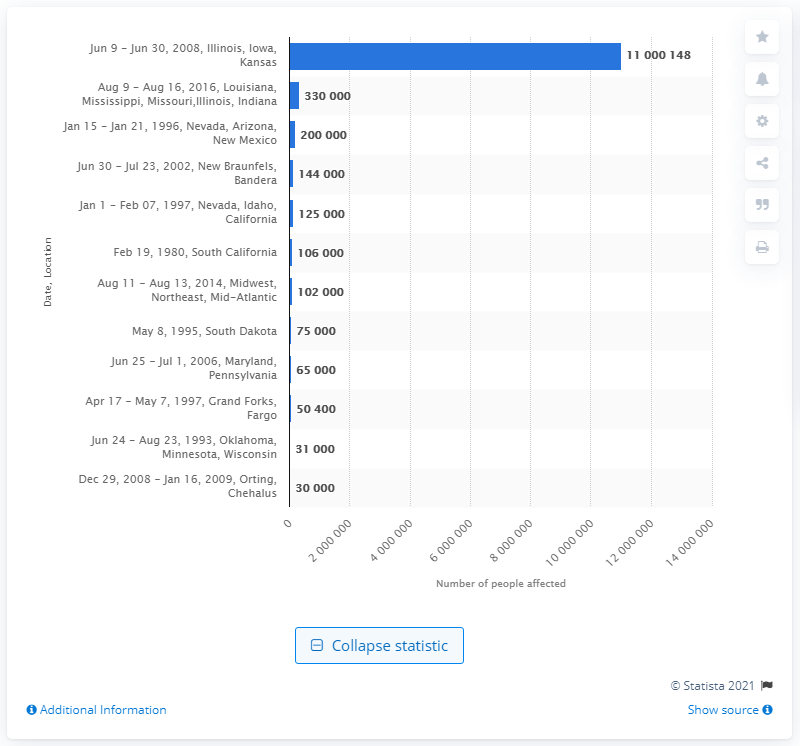Point out several critical features in this image. During the flood that occurred in June 2008, an estimated 11000148 people were affected. 